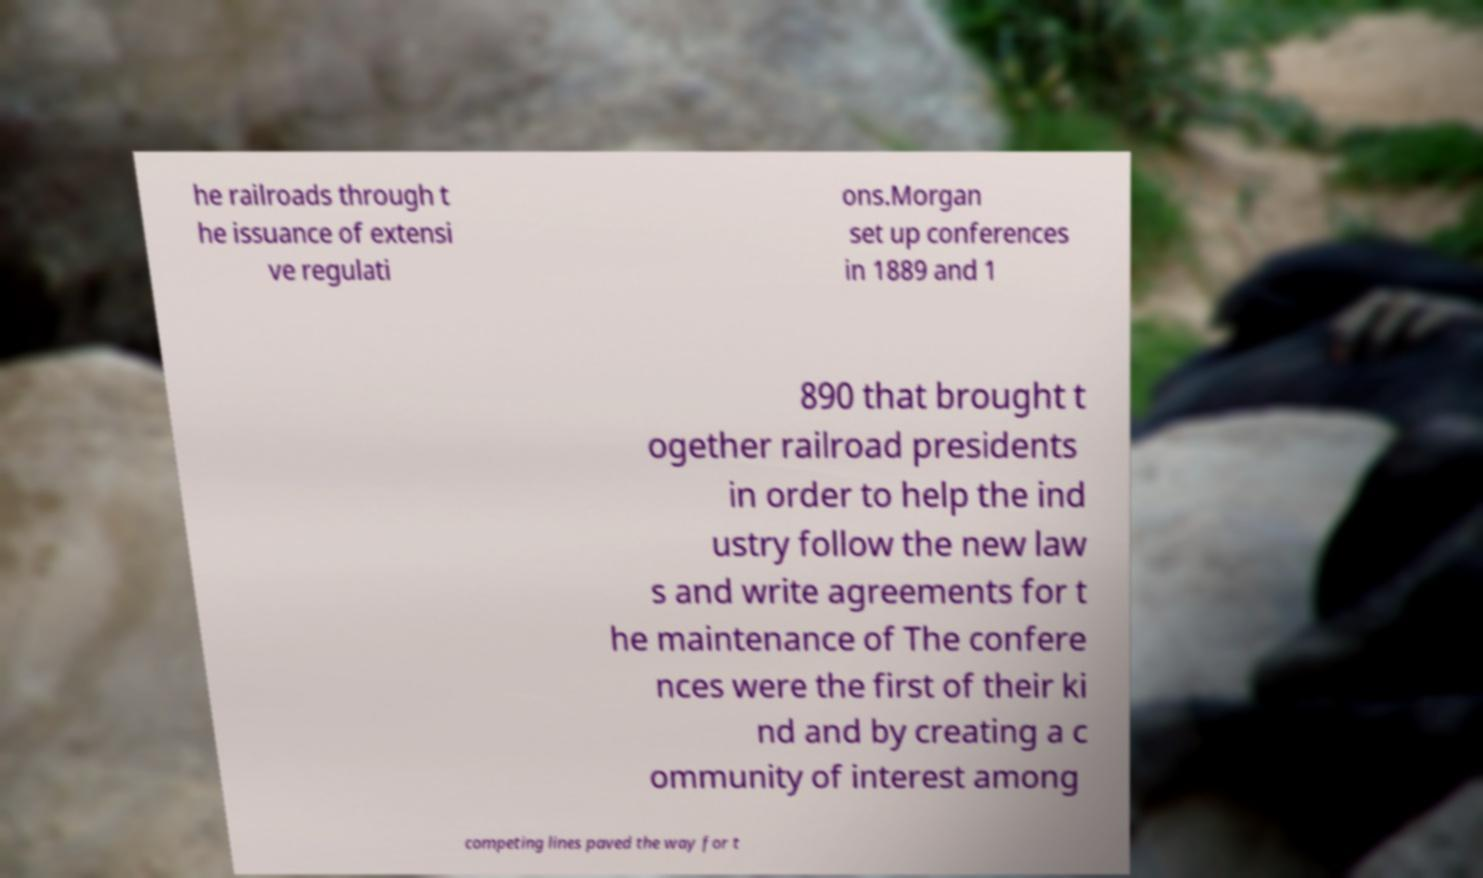There's text embedded in this image that I need extracted. Can you transcribe it verbatim? he railroads through t he issuance of extensi ve regulati ons.Morgan set up conferences in 1889 and 1 890 that brought t ogether railroad presidents in order to help the ind ustry follow the new law s and write agreements for t he maintenance of The confere nces were the first of their ki nd and by creating a c ommunity of interest among competing lines paved the way for t 